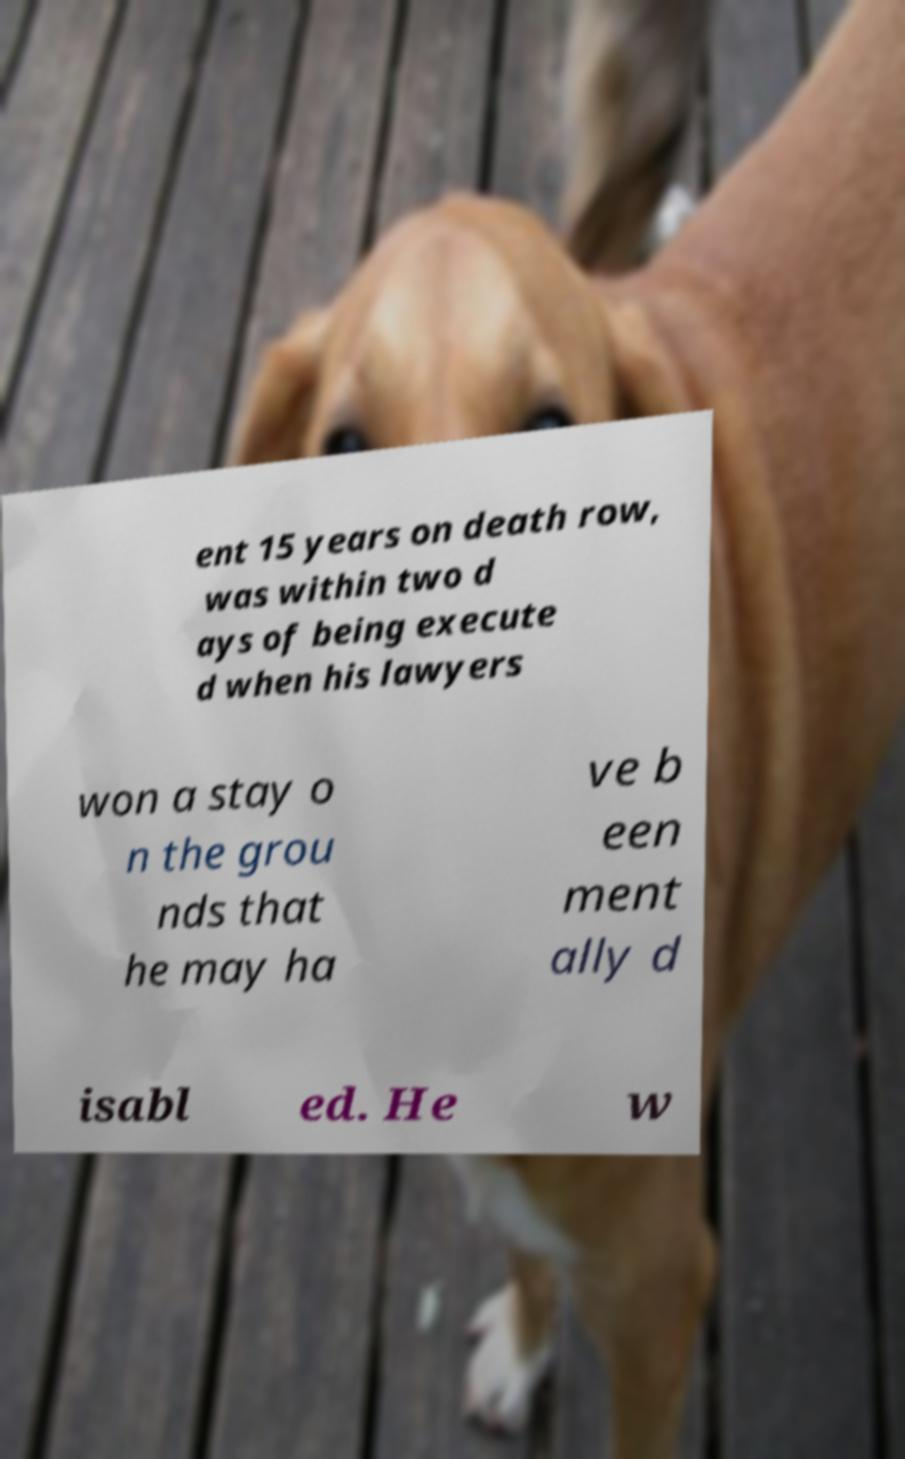What messages or text are displayed in this image? I need them in a readable, typed format. ent 15 years on death row, was within two d ays of being execute d when his lawyers won a stay o n the grou nds that he may ha ve b een ment ally d isabl ed. He w 